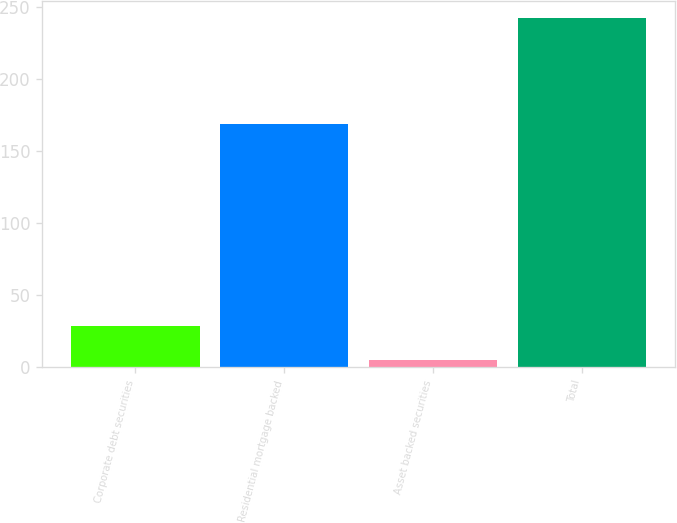Convert chart. <chart><loc_0><loc_0><loc_500><loc_500><bar_chart><fcel>Corporate debt securities<fcel>Residential mortgage backed<fcel>Asset backed securities<fcel>Total<nl><fcel>28.7<fcel>169<fcel>5<fcel>242<nl></chart> 